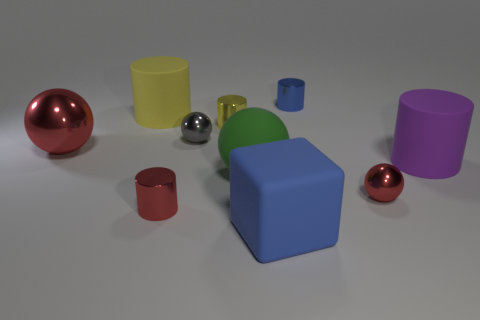Subtract 1 cylinders. How many cylinders are left? 4 Subtract all tiny blue cylinders. How many cylinders are left? 4 Subtract all brown cylinders. Subtract all red cubes. How many cylinders are left? 5 Subtract all blocks. How many objects are left? 9 Subtract all green shiny cylinders. Subtract all small red metal balls. How many objects are left? 9 Add 5 red things. How many red things are left? 8 Add 7 yellow objects. How many yellow objects exist? 9 Subtract 0 brown cylinders. How many objects are left? 10 